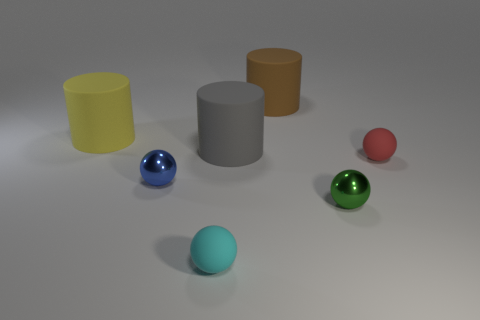What is the color of the matte sphere on the left side of the big thing in front of the large yellow cylinder?
Offer a very short reply. Cyan. What number of things are there?
Your response must be concise. 7. How many matte objects are both behind the yellow rubber thing and to the right of the green ball?
Make the answer very short. 0. Is there any other thing that is the same shape as the large yellow object?
Keep it short and to the point. Yes. What is the shape of the large matte thing behind the yellow cylinder?
Make the answer very short. Cylinder. How many other things are there of the same material as the small cyan sphere?
Keep it short and to the point. 4. What material is the blue ball?
Offer a terse response. Metal. What number of big objects are either yellow matte cylinders or cyan balls?
Your answer should be very brief. 1. There is a large gray cylinder; how many tiny cyan balls are behind it?
Your answer should be very brief. 0. What is the shape of the yellow thing that is the same size as the brown thing?
Your response must be concise. Cylinder. 